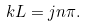<formula> <loc_0><loc_0><loc_500><loc_500>k L = j n \pi .</formula> 